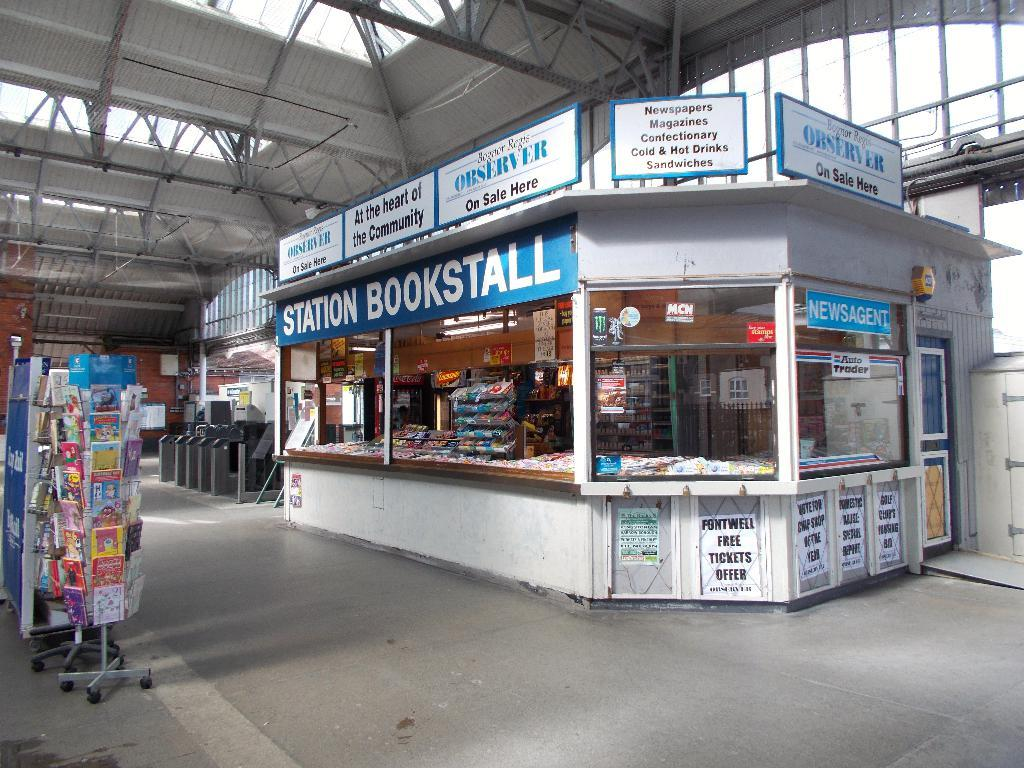<image>
Give a short and clear explanation of the subsequent image. A small store inside a building that has a sign that says Station Bookstall 